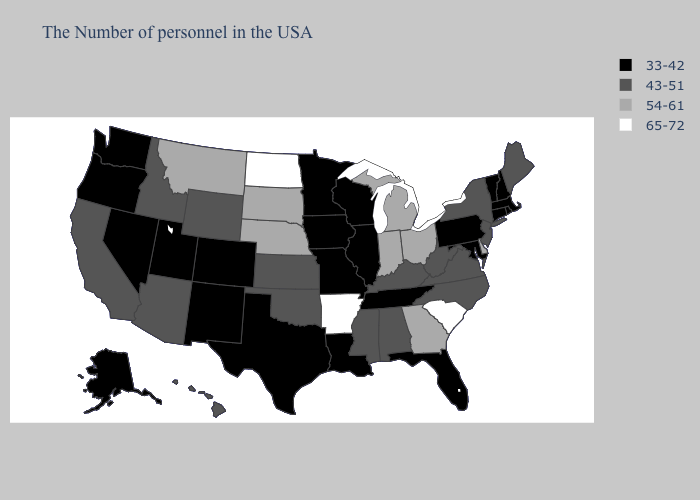What is the value of Massachusetts?
Give a very brief answer. 33-42. Does Alabama have the highest value in the USA?
Quick response, please. No. Name the states that have a value in the range 54-61?
Be succinct. Delaware, Ohio, Georgia, Michigan, Indiana, Nebraska, South Dakota, Montana. What is the value of New Jersey?
Give a very brief answer. 43-51. Name the states that have a value in the range 33-42?
Quick response, please. Massachusetts, Rhode Island, New Hampshire, Vermont, Connecticut, Maryland, Pennsylvania, Florida, Tennessee, Wisconsin, Illinois, Louisiana, Missouri, Minnesota, Iowa, Texas, Colorado, New Mexico, Utah, Nevada, Washington, Oregon, Alaska. Which states have the lowest value in the MidWest?
Keep it brief. Wisconsin, Illinois, Missouri, Minnesota, Iowa. Name the states that have a value in the range 43-51?
Concise answer only. Maine, New York, New Jersey, Virginia, North Carolina, West Virginia, Kentucky, Alabama, Mississippi, Kansas, Oklahoma, Wyoming, Arizona, Idaho, California, Hawaii. What is the value of Vermont?
Short answer required. 33-42. Name the states that have a value in the range 43-51?
Short answer required. Maine, New York, New Jersey, Virginia, North Carolina, West Virginia, Kentucky, Alabama, Mississippi, Kansas, Oklahoma, Wyoming, Arizona, Idaho, California, Hawaii. What is the lowest value in the USA?
Concise answer only. 33-42. Which states have the highest value in the USA?
Short answer required. South Carolina, Arkansas, North Dakota. Does Maine have the same value as Mississippi?
Be succinct. Yes. Name the states that have a value in the range 54-61?
Answer briefly. Delaware, Ohio, Georgia, Michigan, Indiana, Nebraska, South Dakota, Montana. Among the states that border North Carolina , does South Carolina have the lowest value?
Be succinct. No. Among the states that border Illinois , does Kentucky have the highest value?
Answer briefly. No. 